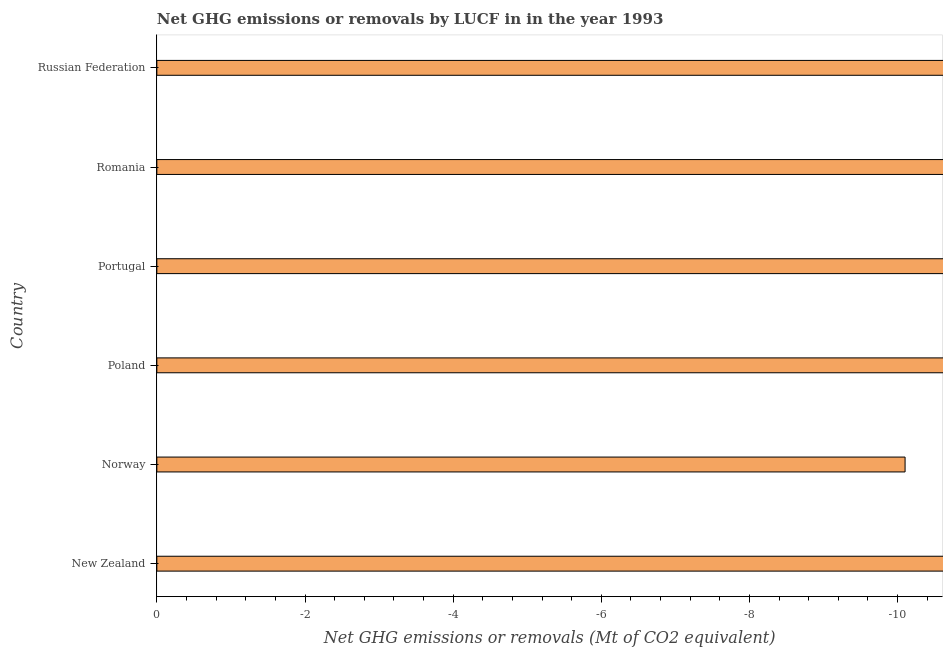Does the graph contain any zero values?
Offer a terse response. Yes. What is the title of the graph?
Make the answer very short. Net GHG emissions or removals by LUCF in in the year 1993. What is the label or title of the X-axis?
Keep it short and to the point. Net GHG emissions or removals (Mt of CO2 equivalent). What is the label or title of the Y-axis?
Provide a short and direct response. Country. What is the average ghg net emissions or removals per country?
Give a very brief answer. 0. Are all the bars in the graph horizontal?
Offer a terse response. Yes. How many countries are there in the graph?
Your response must be concise. 6. Are the values on the major ticks of X-axis written in scientific E-notation?
Your answer should be compact. No. What is the Net GHG emissions or removals (Mt of CO2 equivalent) in New Zealand?
Your response must be concise. 0. What is the Net GHG emissions or removals (Mt of CO2 equivalent) in Norway?
Keep it short and to the point. 0. What is the Net GHG emissions or removals (Mt of CO2 equivalent) in Poland?
Ensure brevity in your answer.  0. 